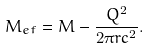Convert formula to latex. <formula><loc_0><loc_0><loc_500><loc_500>M _ { e f } = M - \frac { Q ^ { 2 } } { 2 \pi r c ^ { 2 } } .</formula> 